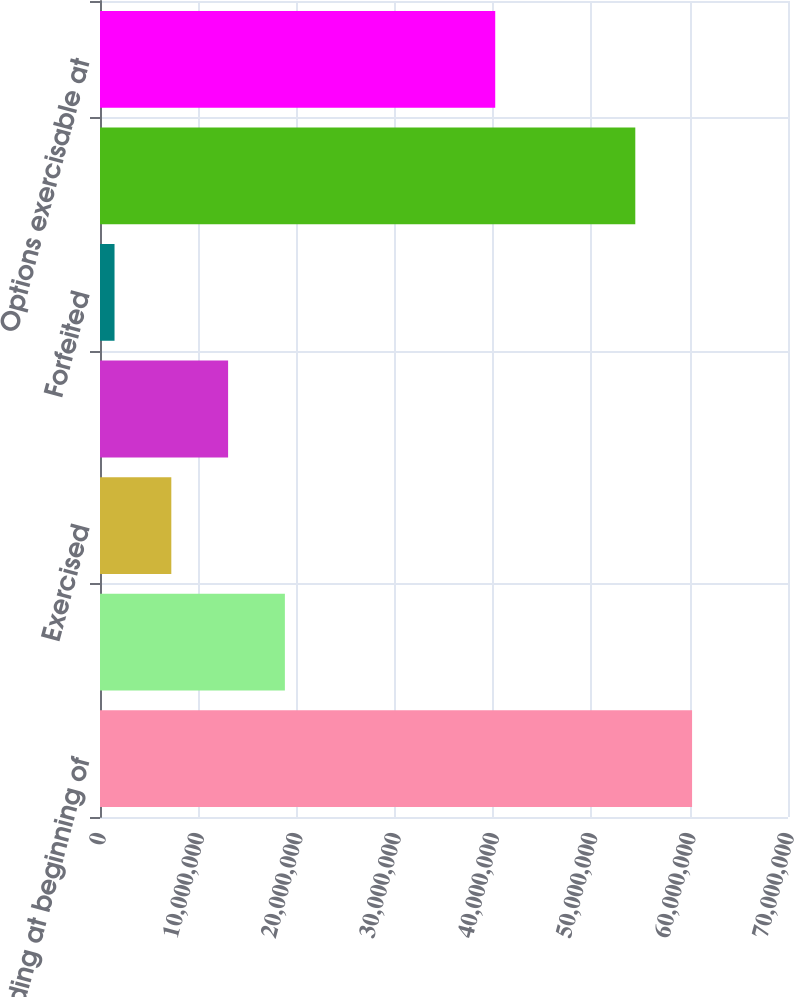Convert chart to OTSL. <chart><loc_0><loc_0><loc_500><loc_500><bar_chart><fcel>Outstanding at beginning of<fcel>Granted<fcel>Exercised<fcel>Exercised delivery deferred<fcel>Forfeited<fcel>Outstanding at end of year<fcel>Options exercisable at<nl><fcel>6.02405e+07<fcel>1.88109e+07<fcel>7.25599e+06<fcel>1.30335e+07<fcel>1.47853e+06<fcel>5.4463e+07<fcel>4.02117e+07<nl></chart> 